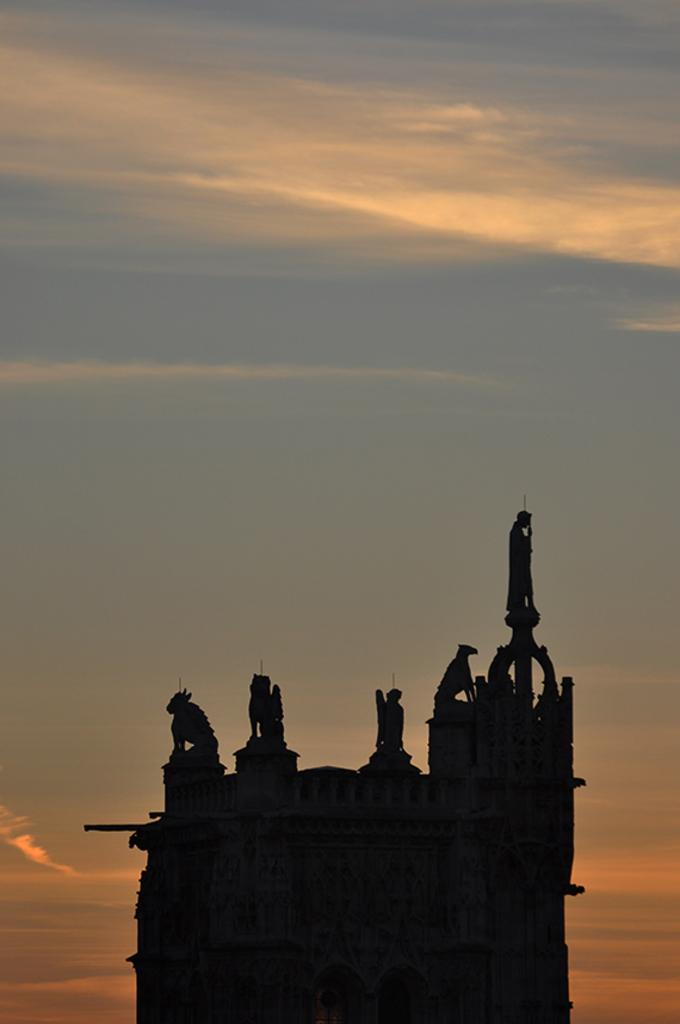What type of structure is present in the image? There is a building in the image. Are there any decorative elements on the building? Yes, the building has sculptures on top of it. What can be seen in the background of the image? The sky is visible in the background of the image. Where is the machine located in the image? There is no machine present in the image. What type of nest can be seen on the building in the image? There is no nest present on the building in the image. 